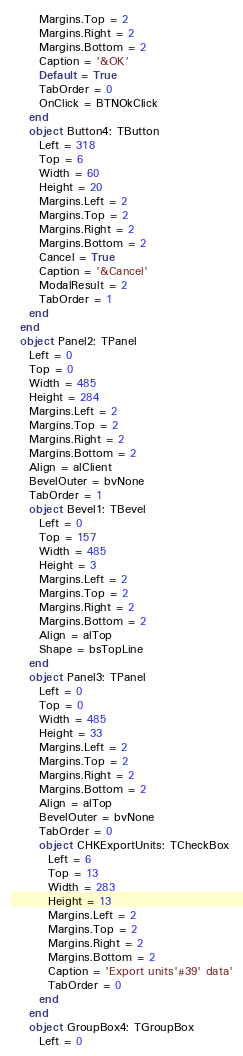Convert code to text. <code><loc_0><loc_0><loc_500><loc_500><_Pascal_>      Margins.Top = 2
      Margins.Right = 2
      Margins.Bottom = 2
      Caption = '&OK'
      Default = True
      TabOrder = 0
      OnClick = BTNOkClick
    end
    object Button4: TButton
      Left = 318
      Top = 6
      Width = 60
      Height = 20
      Margins.Left = 2
      Margins.Top = 2
      Margins.Right = 2
      Margins.Bottom = 2
      Cancel = True
      Caption = '&Cancel'
      ModalResult = 2
      TabOrder = 1
    end
  end
  object Panel2: TPanel
    Left = 0
    Top = 0
    Width = 485
    Height = 284
    Margins.Left = 2
    Margins.Top = 2
    Margins.Right = 2
    Margins.Bottom = 2
    Align = alClient
    BevelOuter = bvNone
    TabOrder = 1
    object Bevel1: TBevel
      Left = 0
      Top = 157
      Width = 485
      Height = 3
      Margins.Left = 2
      Margins.Top = 2
      Margins.Right = 2
      Margins.Bottom = 2
      Align = alTop
      Shape = bsTopLine
    end
    object Panel3: TPanel
      Left = 0
      Top = 0
      Width = 485
      Height = 33
      Margins.Left = 2
      Margins.Top = 2
      Margins.Right = 2
      Margins.Bottom = 2
      Align = alTop
      BevelOuter = bvNone
      TabOrder = 0
      object CHKExportUnits: TCheckBox
        Left = 6
        Top = 13
        Width = 283
        Height = 13
        Margins.Left = 2
        Margins.Top = 2
        Margins.Right = 2
        Margins.Bottom = 2
        Caption = 'Export units'#39' data'
        TabOrder = 0
      end
    end
    object GroupBox4: TGroupBox
      Left = 0</code> 